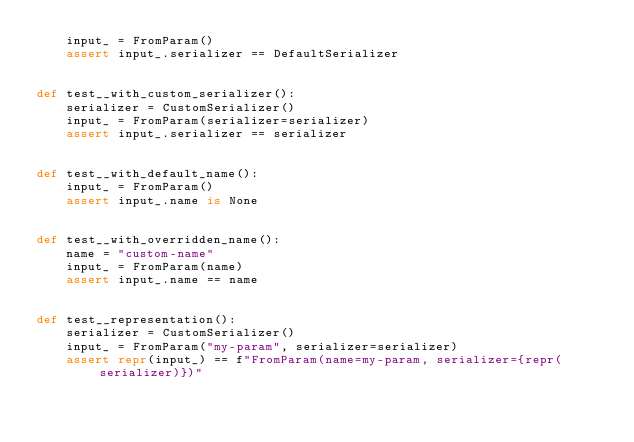Convert code to text. <code><loc_0><loc_0><loc_500><loc_500><_Python_>    input_ = FromParam()
    assert input_.serializer == DefaultSerializer


def test__with_custom_serializer():
    serializer = CustomSerializer()
    input_ = FromParam(serializer=serializer)
    assert input_.serializer == serializer


def test__with_default_name():
    input_ = FromParam()
    assert input_.name is None


def test__with_overridden_name():
    name = "custom-name"
    input_ = FromParam(name)
    assert input_.name == name


def test__representation():
    serializer = CustomSerializer()
    input_ = FromParam("my-param", serializer=serializer)
    assert repr(input_) == f"FromParam(name=my-param, serializer={repr(serializer)})"
</code> 